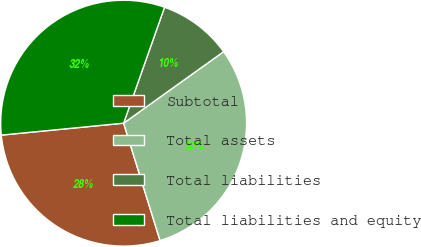Convert chart to OTSL. <chart><loc_0><loc_0><loc_500><loc_500><pie_chart><fcel>Subtotal<fcel>Total assets<fcel>Total liabilities<fcel>Total liabilities and equity<nl><fcel>28.24%<fcel>30.09%<fcel>9.72%<fcel>31.95%<nl></chart> 